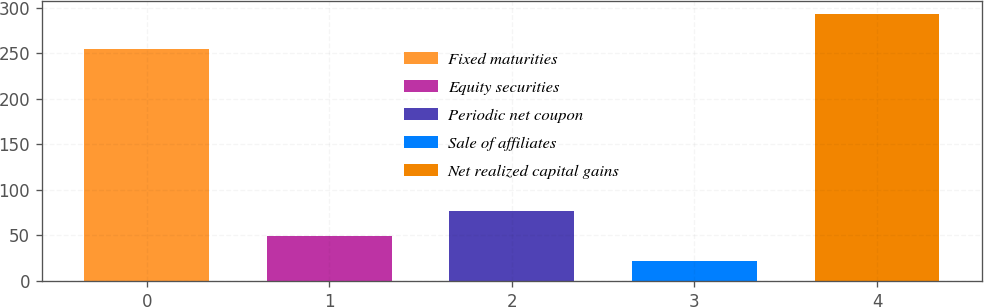Convert chart. <chart><loc_0><loc_0><loc_500><loc_500><bar_chart><fcel>Fixed maturities<fcel>Equity securities<fcel>Periodic net coupon<fcel>Sale of affiliates<fcel>Net realized capital gains<nl><fcel>255<fcel>49.1<fcel>76.2<fcel>22<fcel>293<nl></chart> 